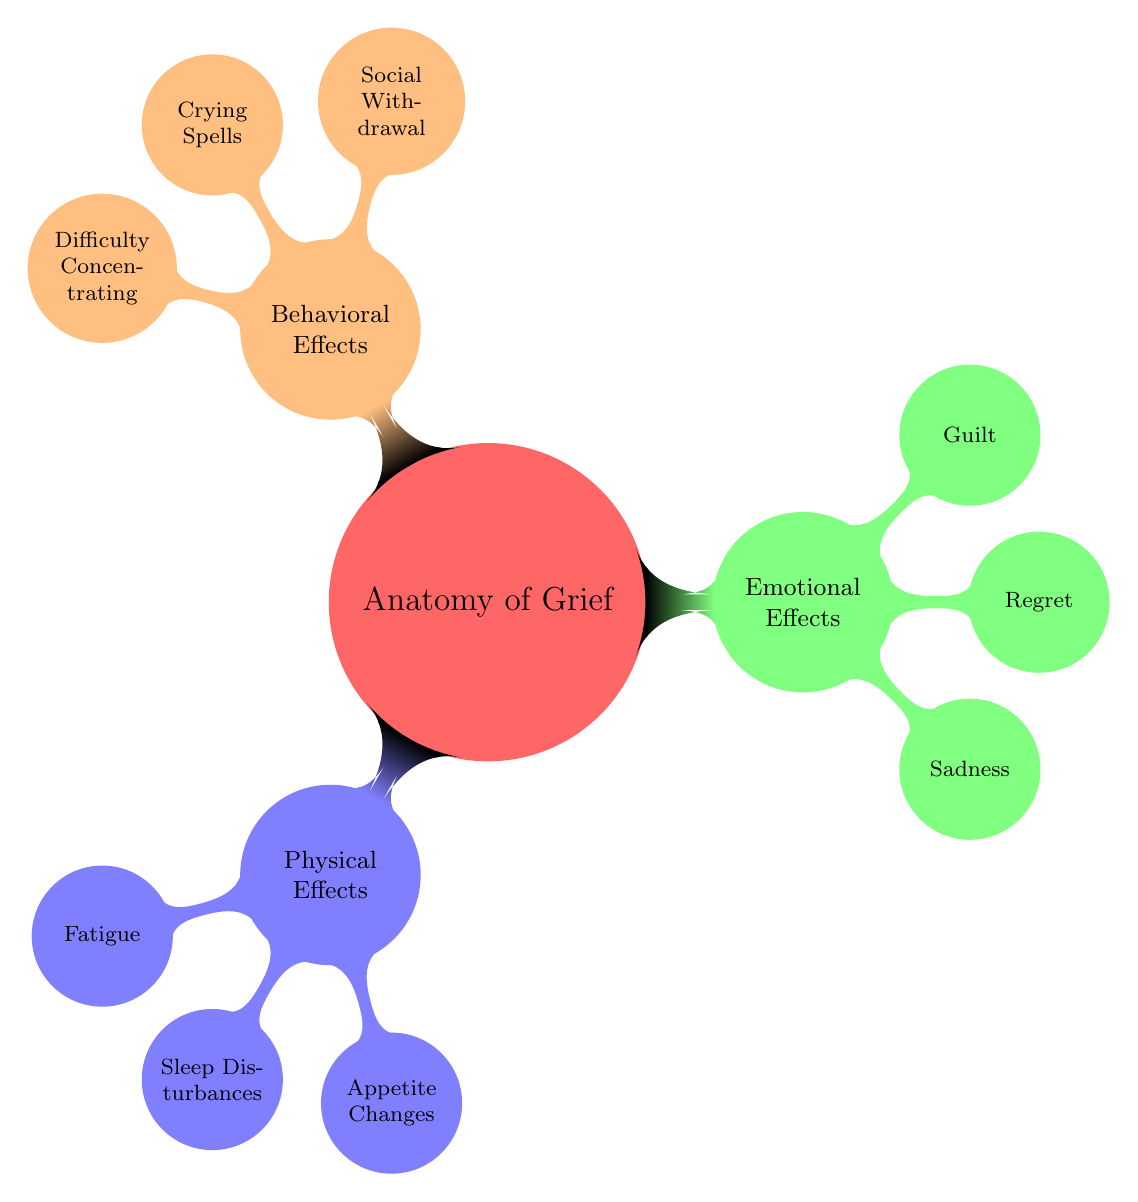What are the three main categories of effects of grief illustrated in the diagram? The diagram presents three main categories: Physical Effects, Emotional Effects, and Behavioral Effects. These categories are clearly labeled as the primary branches of the mind map.
Answer: Physical Effects, Emotional Effects, Behavioral Effects How many physical effects are detailed in the diagram? Within the Physical Effects category, there are three specific effects listed: Fatigue, Sleep Disturbances, and Appetite Changes. Therefore, the total count is three.
Answer: 3 Which emotional effect related to grief is represented first in the diagram? The emotional effects are listed with Sadness as the first node under the Emotional Effects category. It is the first item encountered as you navigate that particular branch of the mind map.
Answer: Sadness What is the relationship between social withdrawal and crying spells in the diagram? Both Social Withdrawal and Crying Spells fall under the Behavioral Effects category. They are sibling nodes branching from the same parent node, signifying that they are both behavioral effects of grief.
Answer: Sibling nodes How many nodes are there in total for the Emotional Effects section? The Emotional Effects section contains three nodes: Sadness, Regret, and Guilt. Therefore, counting each, we arrive at a total of three nodes within this section.
Answer: 3 What can be inferred about the interaction of physical and emotional effects based on the diagram structure? The diagram illustrates separate categories for Physical and Emotional Effects, suggesting that these areas are distinct but interconnected elements of the grieving process. The design implies that grief impacts both physical health and emotional well-being, although they are categorized separately.
Answer: Interconnected elements What is the last behavioral effect listed in the diagram? The last node under the Behavioral Effects category is Difficulty Concentrating. This positioning makes it the final listed effect in that segment of the diagram.
Answer: Difficulty Concentrating 